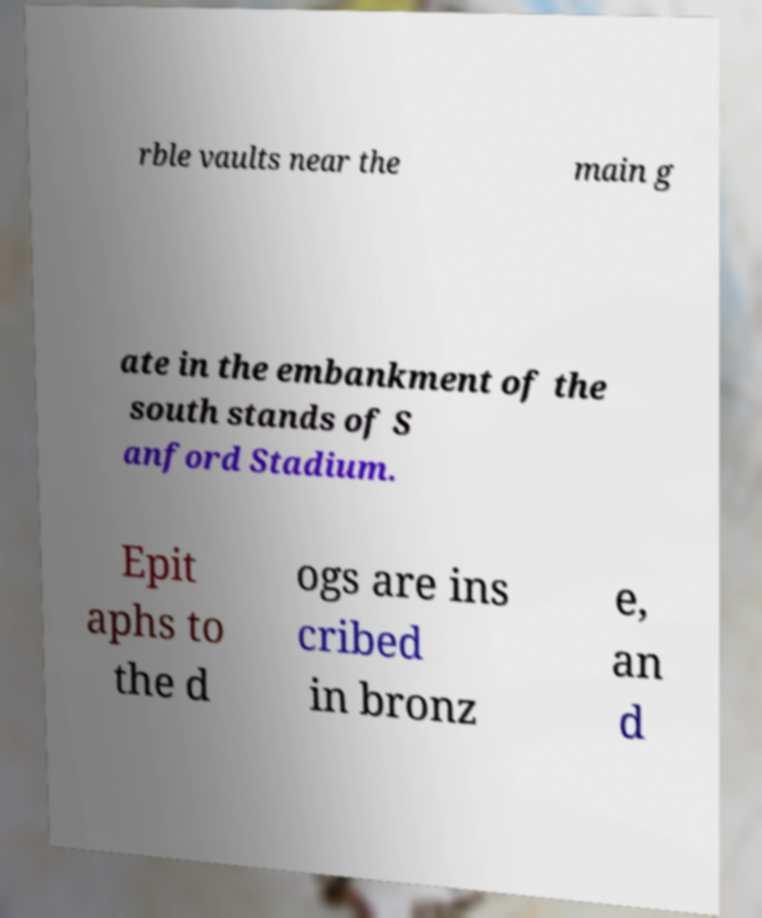Please read and relay the text visible in this image. What does it say? rble vaults near the main g ate in the embankment of the south stands of S anford Stadium. Epit aphs to the d ogs are ins cribed in bronz e, an d 